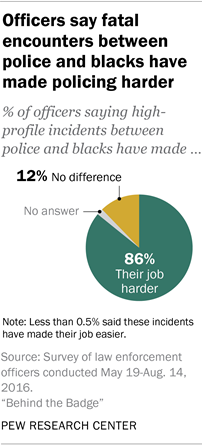Identify some key points in this picture. Is the largest segment three times the value of the smallest segment? No. The value of the largest segment is 86. 